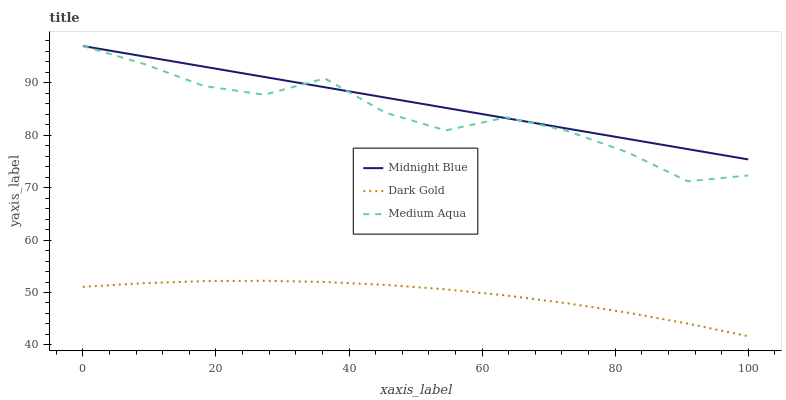Does Dark Gold have the minimum area under the curve?
Answer yes or no. Yes. Does Midnight Blue have the maximum area under the curve?
Answer yes or no. Yes. Does Midnight Blue have the minimum area under the curve?
Answer yes or no. No. Does Dark Gold have the maximum area under the curve?
Answer yes or no. No. Is Midnight Blue the smoothest?
Answer yes or no. Yes. Is Medium Aqua the roughest?
Answer yes or no. Yes. Is Dark Gold the smoothest?
Answer yes or no. No. Is Dark Gold the roughest?
Answer yes or no. No. Does Dark Gold have the lowest value?
Answer yes or no. Yes. Does Midnight Blue have the lowest value?
Answer yes or no. No. Does Midnight Blue have the highest value?
Answer yes or no. Yes. Does Dark Gold have the highest value?
Answer yes or no. No. Is Dark Gold less than Midnight Blue?
Answer yes or no. Yes. Is Medium Aqua greater than Dark Gold?
Answer yes or no. Yes. Does Medium Aqua intersect Midnight Blue?
Answer yes or no. Yes. Is Medium Aqua less than Midnight Blue?
Answer yes or no. No. Is Medium Aqua greater than Midnight Blue?
Answer yes or no. No. Does Dark Gold intersect Midnight Blue?
Answer yes or no. No. 